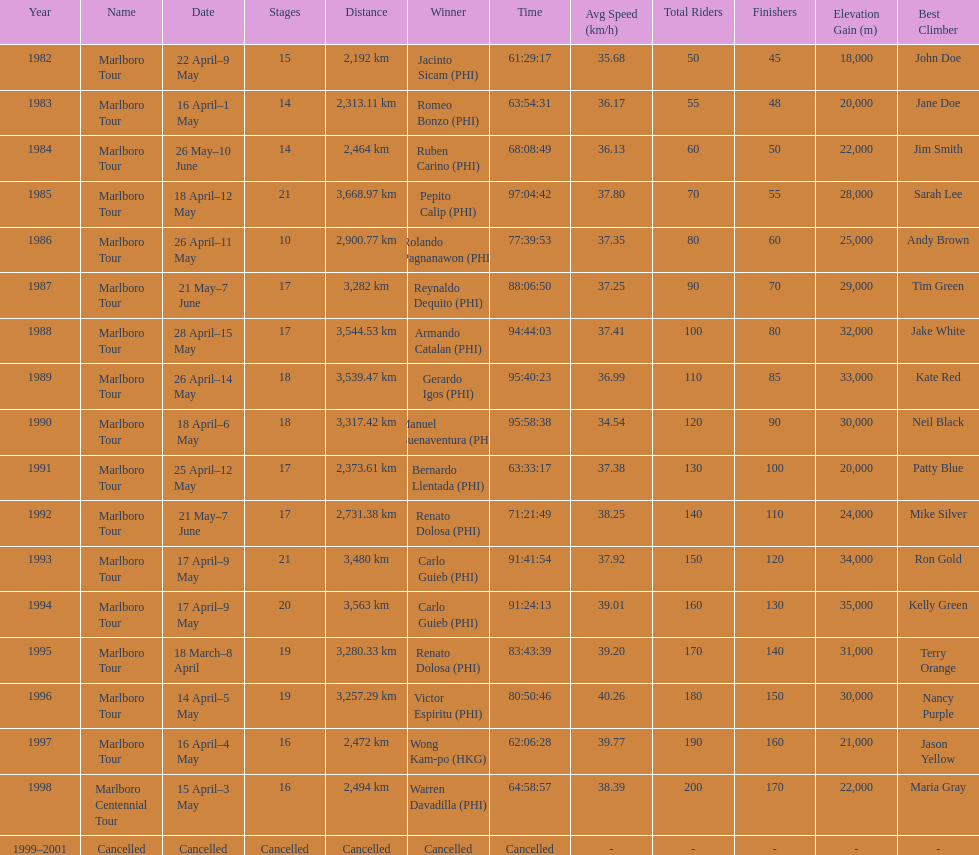Who was the only winner to have their time below 61:45:00? Jacinto Sicam. 